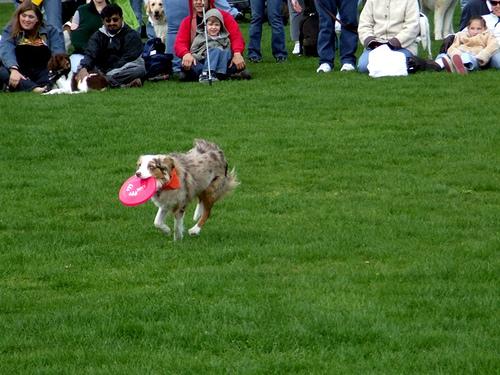What is the dog carrying?
Short answer required. Frisbee. What breed of dog is this?
Be succinct. Australian shepherd. Is the dog trained?
Give a very brief answer. Yes. 